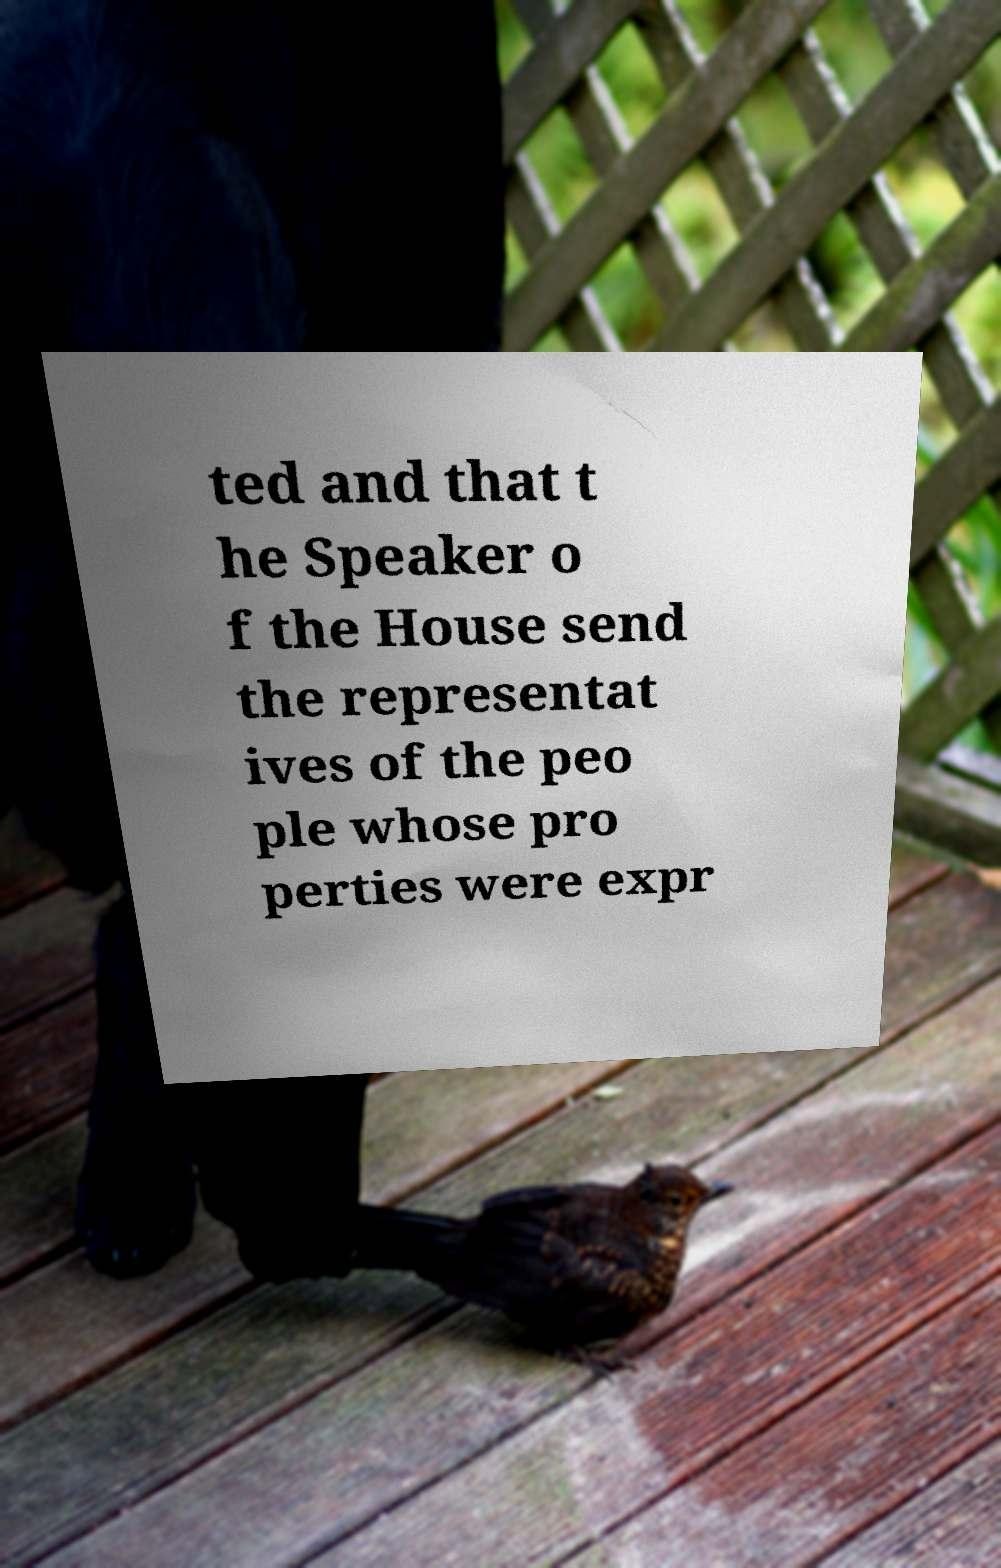Could you assist in decoding the text presented in this image and type it out clearly? ted and that t he Speaker o f the House send the representat ives of the peo ple whose pro perties were expr 